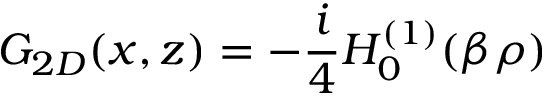<formula> <loc_0><loc_0><loc_500><loc_500>G _ { 2 D } ( x , z ) = - \frac { i } { 4 } H _ { 0 } ^ { ( 1 ) } ( \beta \rho )</formula> 